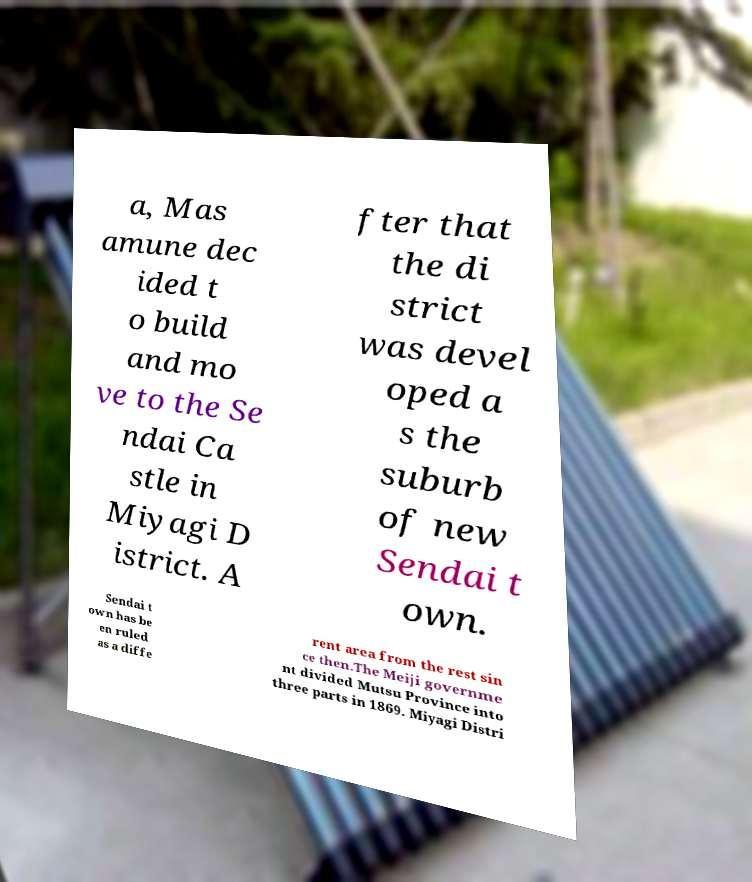Please read and relay the text visible in this image. What does it say? a, Mas amune dec ided t o build and mo ve to the Se ndai Ca stle in Miyagi D istrict. A fter that the di strict was devel oped a s the suburb of new Sendai t own. Sendai t own has be en ruled as a diffe rent area from the rest sin ce then.The Meiji governme nt divided Mutsu Province into three parts in 1869. Miyagi Distri 